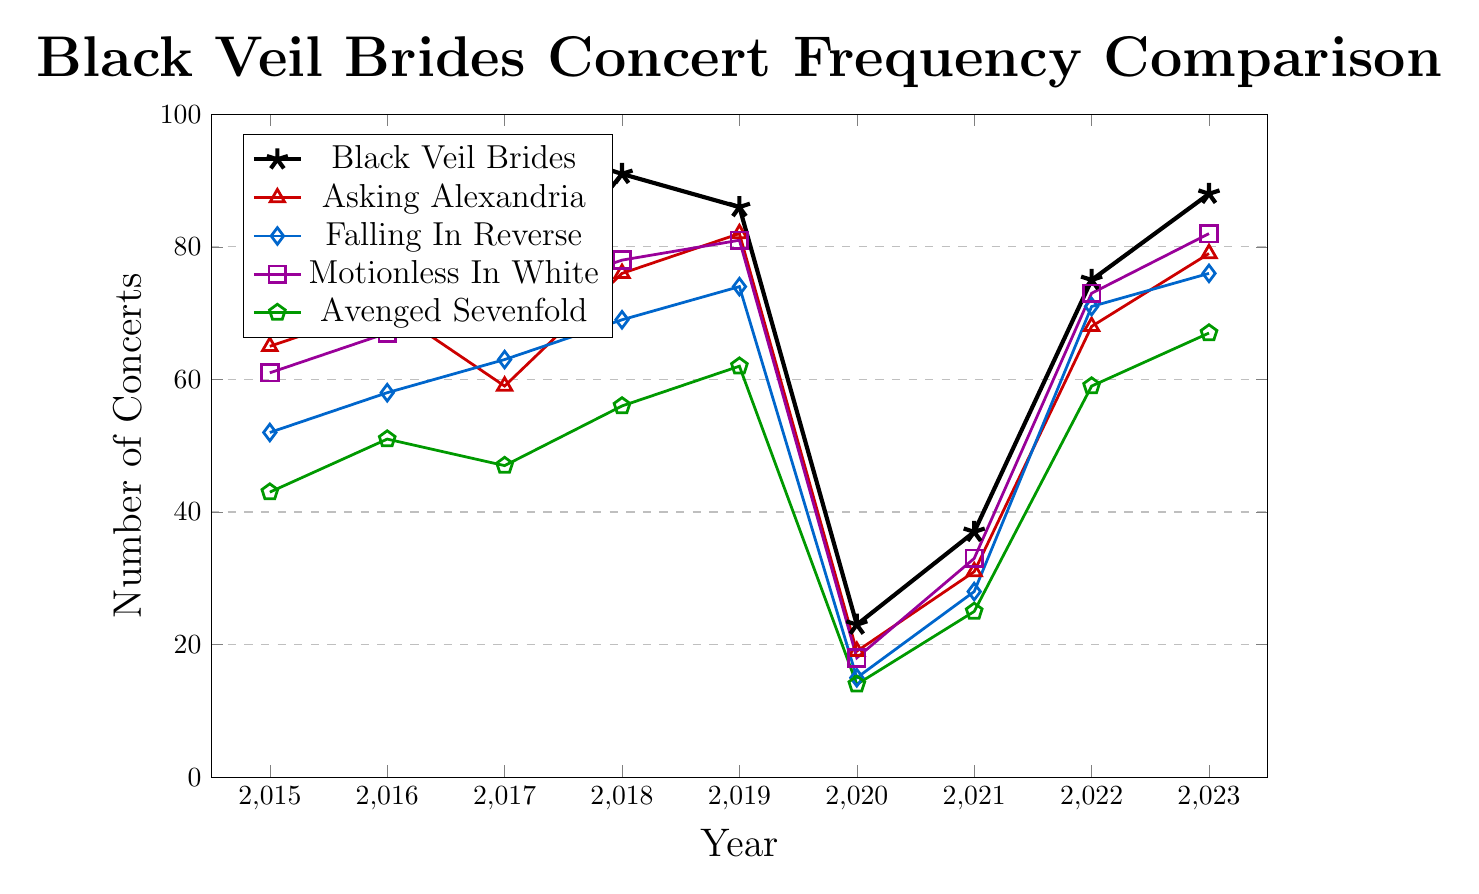Which year saw the highest number of Black Veil Brides concerts? Look at the peak point on the line representing Black Veil Brides, which is the highest point on the chart. The year corresponding to this highest point is 2018 with 91 concerts.
Answer: 2018 How did the number of Black Veil Brides' concerts in 2020 compare to their number in 2019? Compare the values for Black Veil Brides in 2019 and 2020. In 2019, there were 86 concerts, while in 2020, there were 23 concerts.
Answer: 63 fewer Which band had the highest number of concerts in 2019? Compare the values for each band in 2019. Motionless In White had 81 concerts, Black Veil Brides had 86 concerts, Falling In Reverse had 74 concerts, and Asking Alexandria had 82 concerts. Thus, Black Veil Brides had the highest number of concerts.
Answer: Black Veil Brides What is the average number of concerts per year for Black Veil Brides from 2020 to 2022? Sum the number of concerts for 2020, 2021, and 2022, then divide by 3. (23+37+75)/3 = 45
Answer: 45 During which years did Asking Alexandria perform more concerts than Falling In Reverse? Compare the values for both bands year by year. In 2015 (65 vs 52), 2016 (71 vs 58), 2018 (76 vs 69), 2019 (82 vs 74), 2021 (31 vs 28), and 2023 (79 vs 76), Asking Alexandria performed more concerts than Falling In Reverse.
Answer: 2015, 2016, 2018, 2019, 2021, 2023 Which band had the lowest number of concerts in 2020 and how many were there? Compare the values for all bands in 2020. Avenged Sevenfold had the lowest with 14 concerts.
Answer: Avenged Sevenfold, 14 By how much did the number of concerts for Motionless In White increase from 2020 to 2021? Subtract the number of concerts in 2020 from the number in 2021 for Motionless In White. 33 - 18 = 15
Answer: 15 Which band experienced the greatest increase in concert numbers from 2021 to 2022? Calculate the increase for each band from 2021 to 2022 and find the greatest. Black Veil Brides: (75-37)=38, Asking Alexandria: (68-31)=37, Falling In Reverse: (71-28)=43, Motionless In White: (73-33)=40, Avenged Sevenfold: (59-25)=34. The greatest increase was for Falling In Reverse with 43 concerts.
Answer: Falling In Reverse What was the difference between the number of concerts performed by Black Veil Brides and Avenged Sevenfold in 2017? Subtract Avenged Sevenfold's number of concerts from Black Veil Brides' number of concerts in 2017. 69 - 47 = 22
Answer: 22 